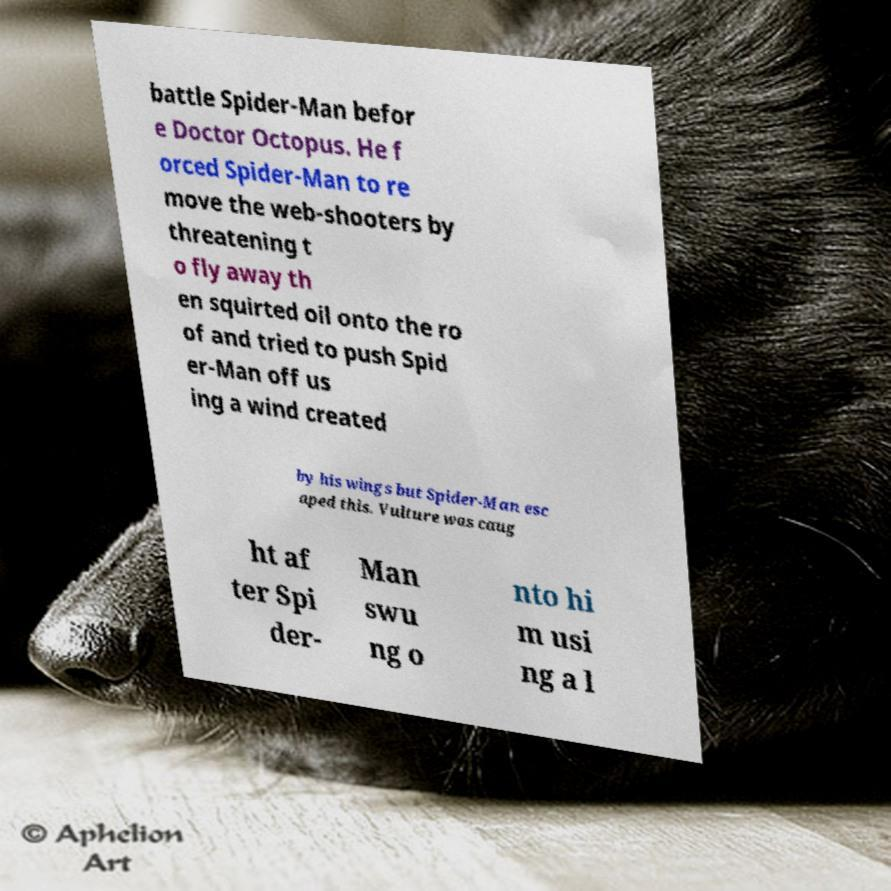Please identify and transcribe the text found in this image. battle Spider-Man befor e Doctor Octopus. He f orced Spider-Man to re move the web-shooters by threatening t o fly away th en squirted oil onto the ro of and tried to push Spid er-Man off us ing a wind created by his wings but Spider-Man esc aped this. Vulture was caug ht af ter Spi der- Man swu ng o nto hi m usi ng a l 